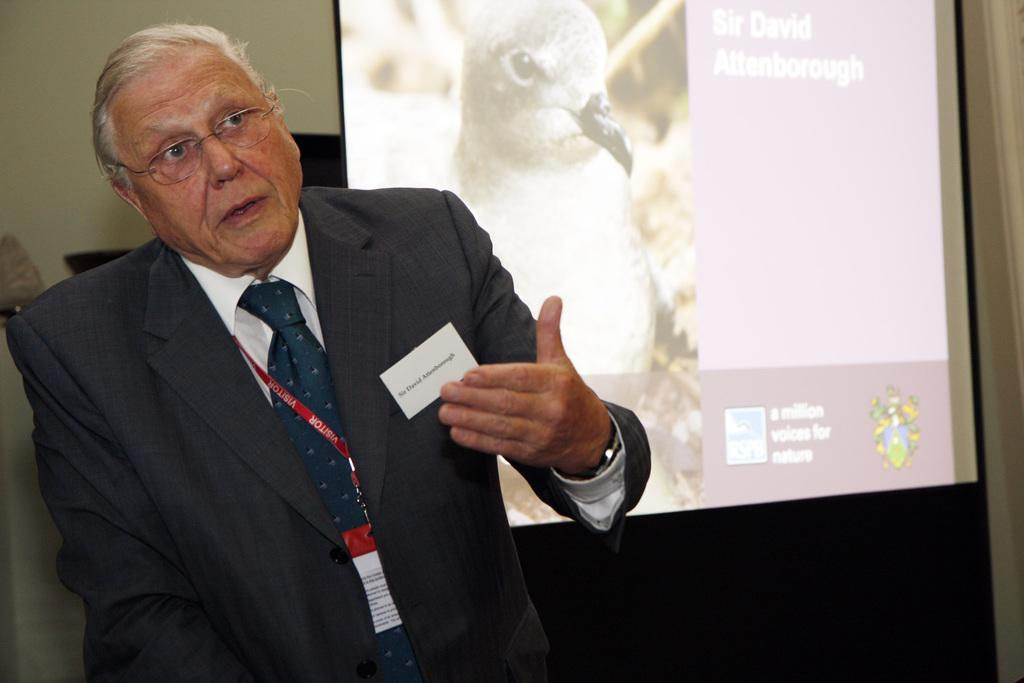What is the man in the image wearing? The man is wearing a formal suit. What is hanging around the man's neck? The man has an ID card around his neck. What can be seen on the projector screen in the image? There is a bird depicted on the projector screen. What might the man be attending or presenting in the image? The presence of a formal suit and a projector screen suggests that the man might be attending or presenting at a formal event or meeting. What type of jelly can be seen playing the drums in the image? There is no jelly or drum present in the image. 